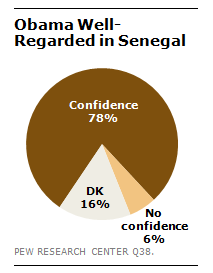Indicate a few pertinent items in this graphic. The difference between the highest and lowest value is 72. The color grey in a pie graph represents a portion of data that is not clearly classified as one of the other three categories. 